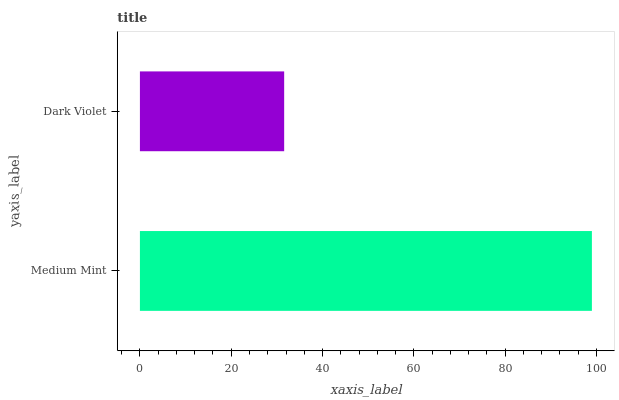Is Dark Violet the minimum?
Answer yes or no. Yes. Is Medium Mint the maximum?
Answer yes or no. Yes. Is Dark Violet the maximum?
Answer yes or no. No. Is Medium Mint greater than Dark Violet?
Answer yes or no. Yes. Is Dark Violet less than Medium Mint?
Answer yes or no. Yes. Is Dark Violet greater than Medium Mint?
Answer yes or no. No. Is Medium Mint less than Dark Violet?
Answer yes or no. No. Is Medium Mint the high median?
Answer yes or no. Yes. Is Dark Violet the low median?
Answer yes or no. Yes. Is Dark Violet the high median?
Answer yes or no. No. Is Medium Mint the low median?
Answer yes or no. No. 